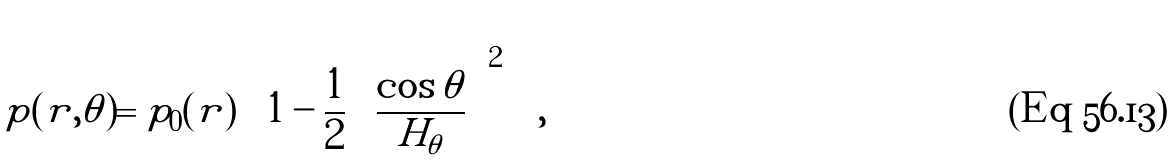Convert formula to latex. <formula><loc_0><loc_0><loc_500><loc_500>p ( r , \theta ) = p _ { 0 } ( r ) \left [ 1 - \frac { 1 } { 2 } \left ( \frac { \cos \theta } { H _ { \theta } } \right ) ^ { 2 } \right ] ,</formula> 